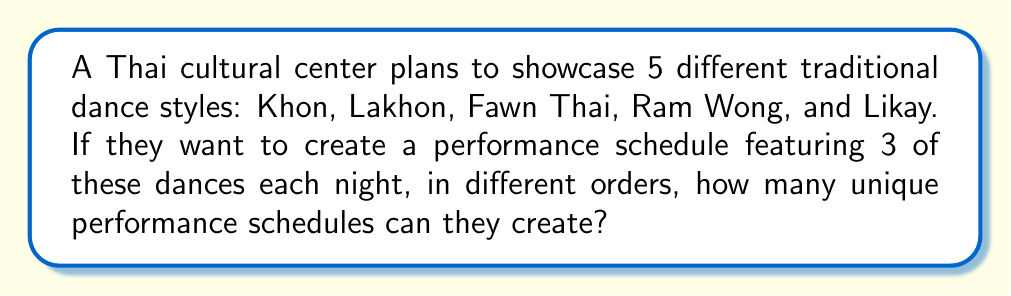Help me with this question. Let's approach this step-by-step:

1) This is a permutation problem. We are selecting 3 dances out of 5 and arranging them in order.

2) The formula for permutations is:

   $$P(n,r) = \frac{n!}{(n-r)!}$$

   Where $n$ is the total number of items to choose from, and $r$ is the number of items being chosen.

3) In this case, $n = 5$ (total number of dance styles) and $r = 3$ (number of dances per night).

4) Plugging these values into our formula:

   $$P(5,3) = \frac{5!}{(5-3)!} = \frac{5!}{2!}$$

5) Expand this:
   $$\frac{5 \times 4 \times 3 \times 2!}{2!}$$

6) The 2! cancels out in the numerator and denominator:
   $$5 \times 4 \times 3 = 60$$

Therefore, the cultural center can create 60 unique performance schedules.
Answer: 60 